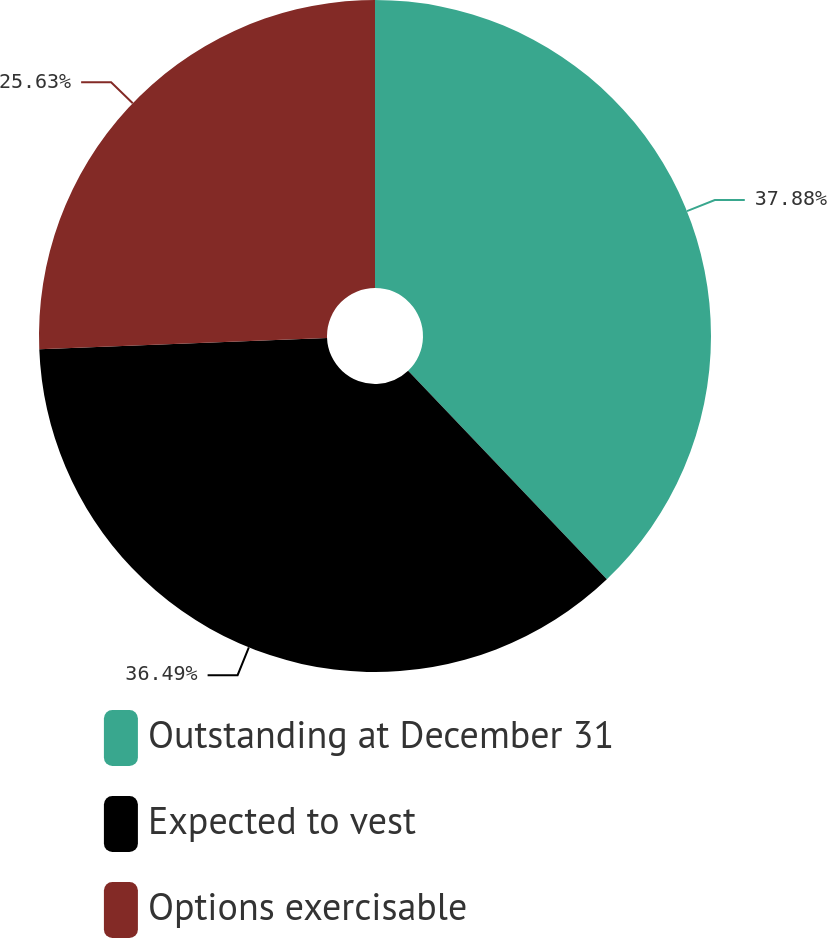Convert chart to OTSL. <chart><loc_0><loc_0><loc_500><loc_500><pie_chart><fcel>Outstanding at December 31<fcel>Expected to vest<fcel>Options exercisable<nl><fcel>37.88%<fcel>36.49%<fcel>25.63%<nl></chart> 